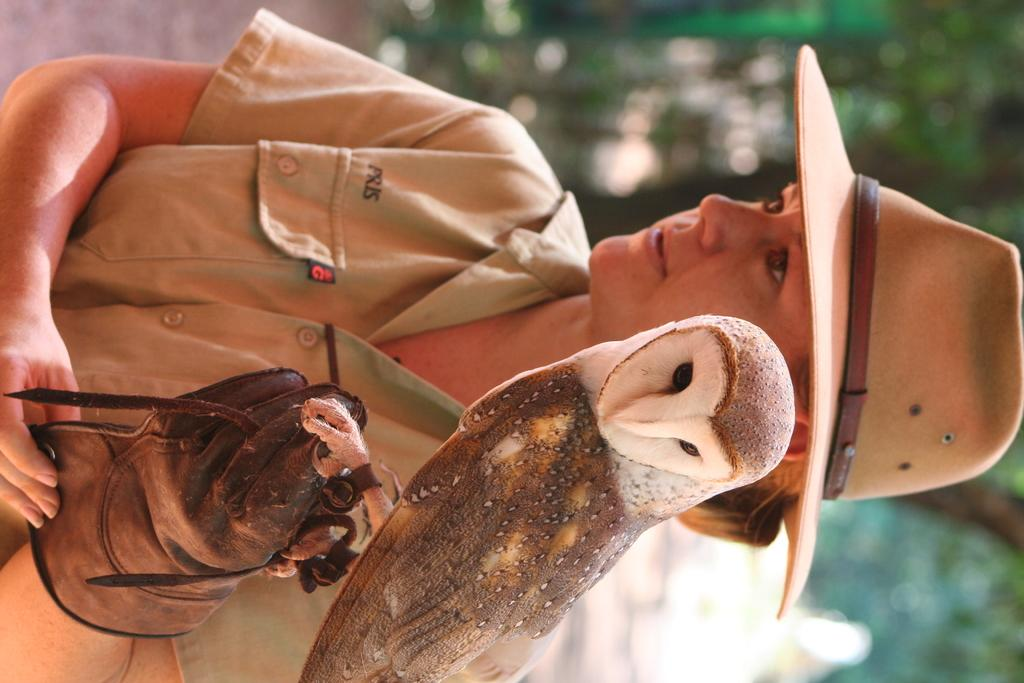What is the main subject of the image? The main subject of the image is a woman. What is the woman doing in the image? The woman is standing and holding a bird in her hands. How much wealth does the woman have in the image? There is no information about the woman's wealth in the image. What type of milk is the bird drinking from the woman's hands? There is no milk present in the image; the woman is holding a bird in her hands. 